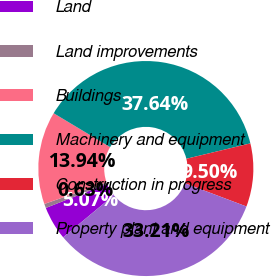<chart> <loc_0><loc_0><loc_500><loc_500><pie_chart><fcel>Land<fcel>Land improvements<fcel>Buildings<fcel>Machinery and equipment<fcel>Construction in progress<fcel>Property plant and equipment<nl><fcel>5.07%<fcel>0.63%<fcel>13.94%<fcel>37.64%<fcel>9.5%<fcel>33.21%<nl></chart> 